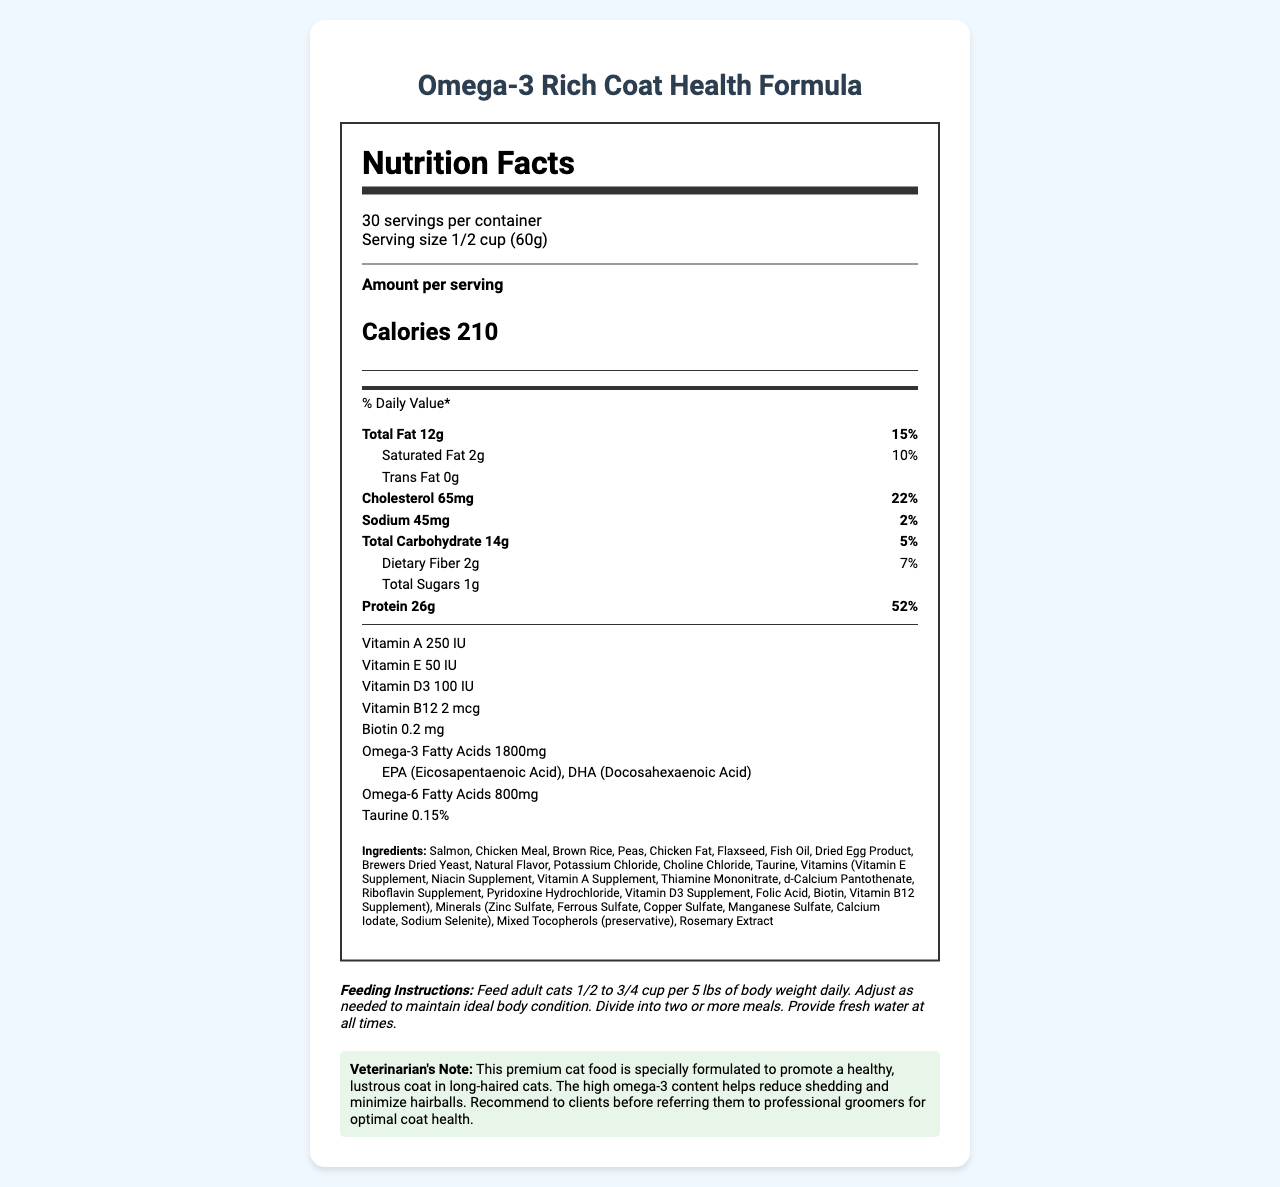what is the serving size? The serving size is specified in the document as "1/2 cup (60g)".
Answer: 1/2 cup (60g) how many calories are there per serving? The document states that there are 210 calories per serving.
Answer: 210 what is the total fat content per serving? The total fat content per serving is listed as "12g".
Answer: 12g how much dietary fiber is present in a serving? The document lists the dietary fiber content as "2g".
Answer: 2g what are the main ingredients of the cat food? The document lists a detailed set of ingredients, starting with Salmon and ending with Rosemary Extract.
Answer: Salmon, Chicken Meal, Brown Rice, Peas, Chicken Fat, Flaxseed, Fish Oil, Dried Egg Product, Brewers Dried Yeast, Natural Flavor, Potassium Chloride, Choline Chloride, Taurine, Vitamins, Minerals, Mixed Tocopherols, Rosemary Extract how much protein does one serving provide? The protein content per serving is specified as "26g".
Answer: 26g what is the daily value percentage for cholesterol? The document specifies that the daily value percentage for cholesterol is 22%.
Answer: 22% which vitamins are included in the cat food? A. Vitamin A, Vitamin C B. Vitamin E, Vitamin K C. Vitamin D3, Vitamin B12 D. Vitamin C, Biotin The vitamins listed in the document under vitamins are Vitamin A, Vitamin E, Vitamin D3, Vitamin B12, and Biotin. Among the options, C. Vitamin D3, Vitamin B12 is correct.
Answer: C. Vitamin D3, Vitamin B12 what are the types of omega-3 fatty acids included? A. ALA, EPA B. EPA, DHA C. DHA, DPA D. ALA, DPA The document specifies omega-3 fatty acids as EPA (Eicosapentaenoic Acid) and DHA (Docosahexaenoic Acid).
Answer: B. EPA, DHA does the product contain trans fat? The document shows that trans fat content is listed as "0g", indicating there is no trans fat in the product.
Answer: No summarize the main purpose of this cat food The document describes a specialized cat food, Omega-3 Rich Coat Health Formula, aimed at improving coat health in long-haired cats, highlighting its omega-3 content, nutritional benefits, and feeding guidelines.
Answer: This cat food, Omega-3 Rich Coat Health Formula, is designed to promote a healthy, lustrous coat in long-haired cats, with high omega-3 content to reduce shedding and minimize hairballs. It features a balanced nutritional profile including proteins, vitamins, and minerals. The product includes feeding instructions and comes with a veterinarian's note recommending it for optimal coat health. how many servings are there per container? The document states that there are 30 servings per container.
Answer: 30 is there any information about the manufacturing process? The document does not provide any details about the manufacturing process of the cat food.
Answer: Cannot be determined 